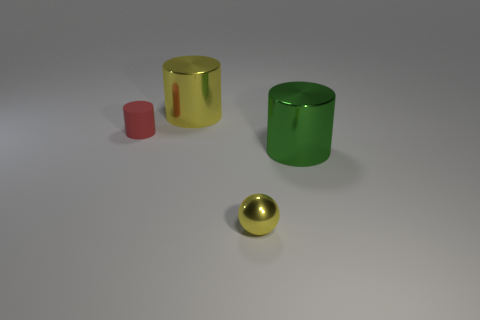Subtract all small red cylinders. How many cylinders are left? 2 Add 4 small cyan metal cubes. How many objects exist? 8 Subtract 1 cylinders. How many cylinders are left? 2 Subtract all balls. How many objects are left? 3 Add 3 large green cylinders. How many large green cylinders exist? 4 Subtract 0 blue cubes. How many objects are left? 4 Subtract all purple spheres. Subtract all brown cylinders. How many spheres are left? 1 Subtract all rubber objects. Subtract all red matte objects. How many objects are left? 2 Add 4 metal objects. How many metal objects are left? 7 